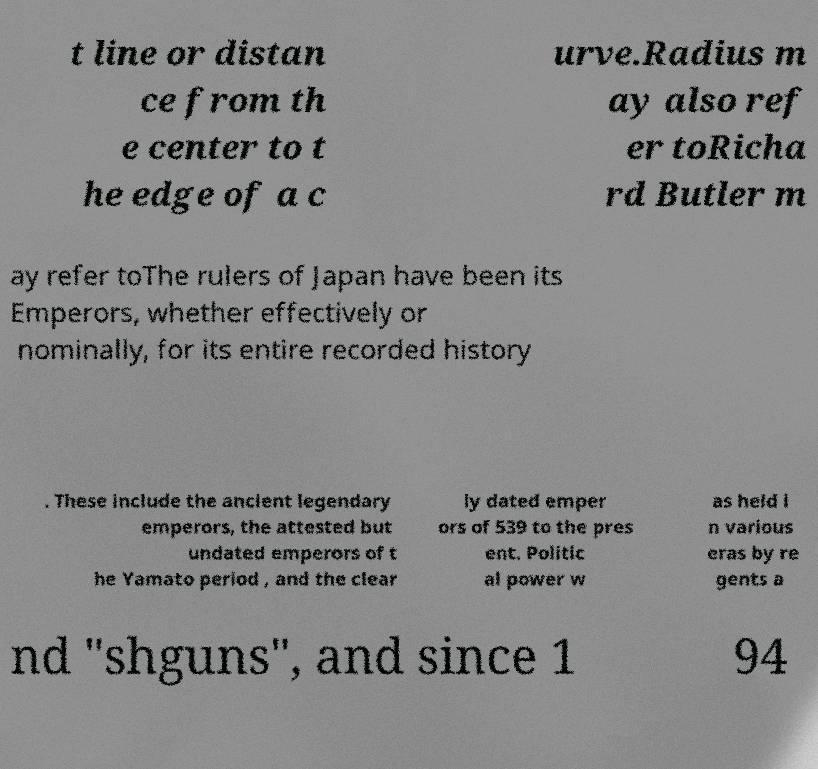Can you read and provide the text displayed in the image?This photo seems to have some interesting text. Can you extract and type it out for me? t line or distan ce from th e center to t he edge of a c urve.Radius m ay also ref er toRicha rd Butler m ay refer toThe rulers of Japan have been its Emperors, whether effectively or nominally, for its entire recorded history . These include the ancient legendary emperors, the attested but undated emperors of t he Yamato period , and the clear ly dated emper ors of 539 to the pres ent. Politic al power w as held i n various eras by re gents a nd "shguns", and since 1 94 